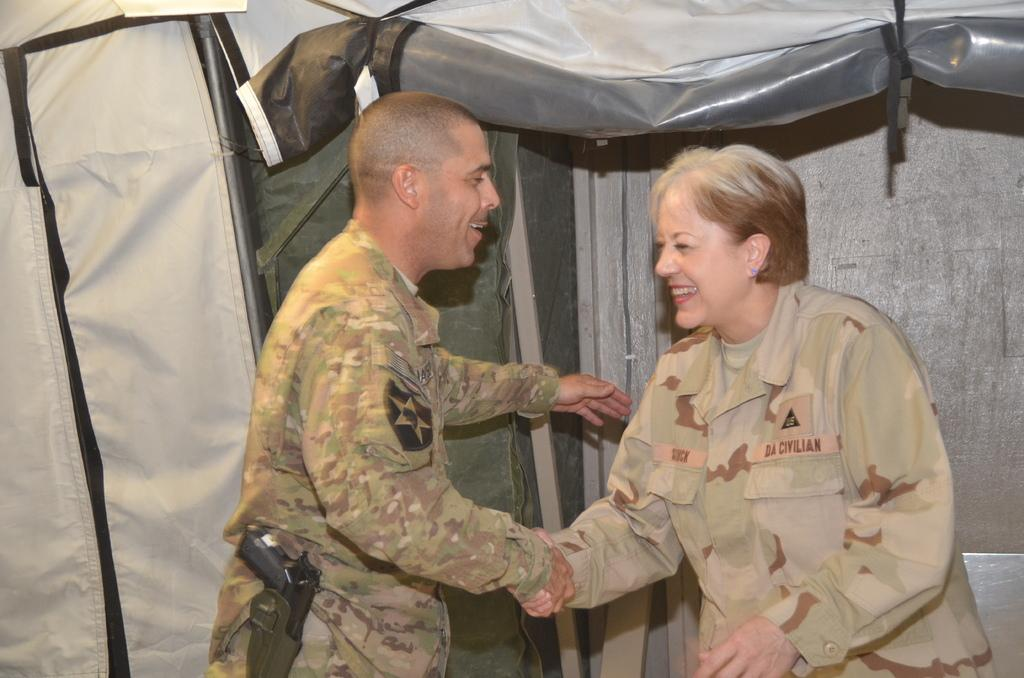How many people are in the image? There are two people in the image. What are the people doing in the image? The people are standing and smiling, and they are holding hands. What can be seen in the background of the image? There is a tent in the background of the image. What time is displayed on the clock in the image? There is no clock present in the image. Can you tell me how many rivers are visible in the image? There are no rivers visible in the image. 